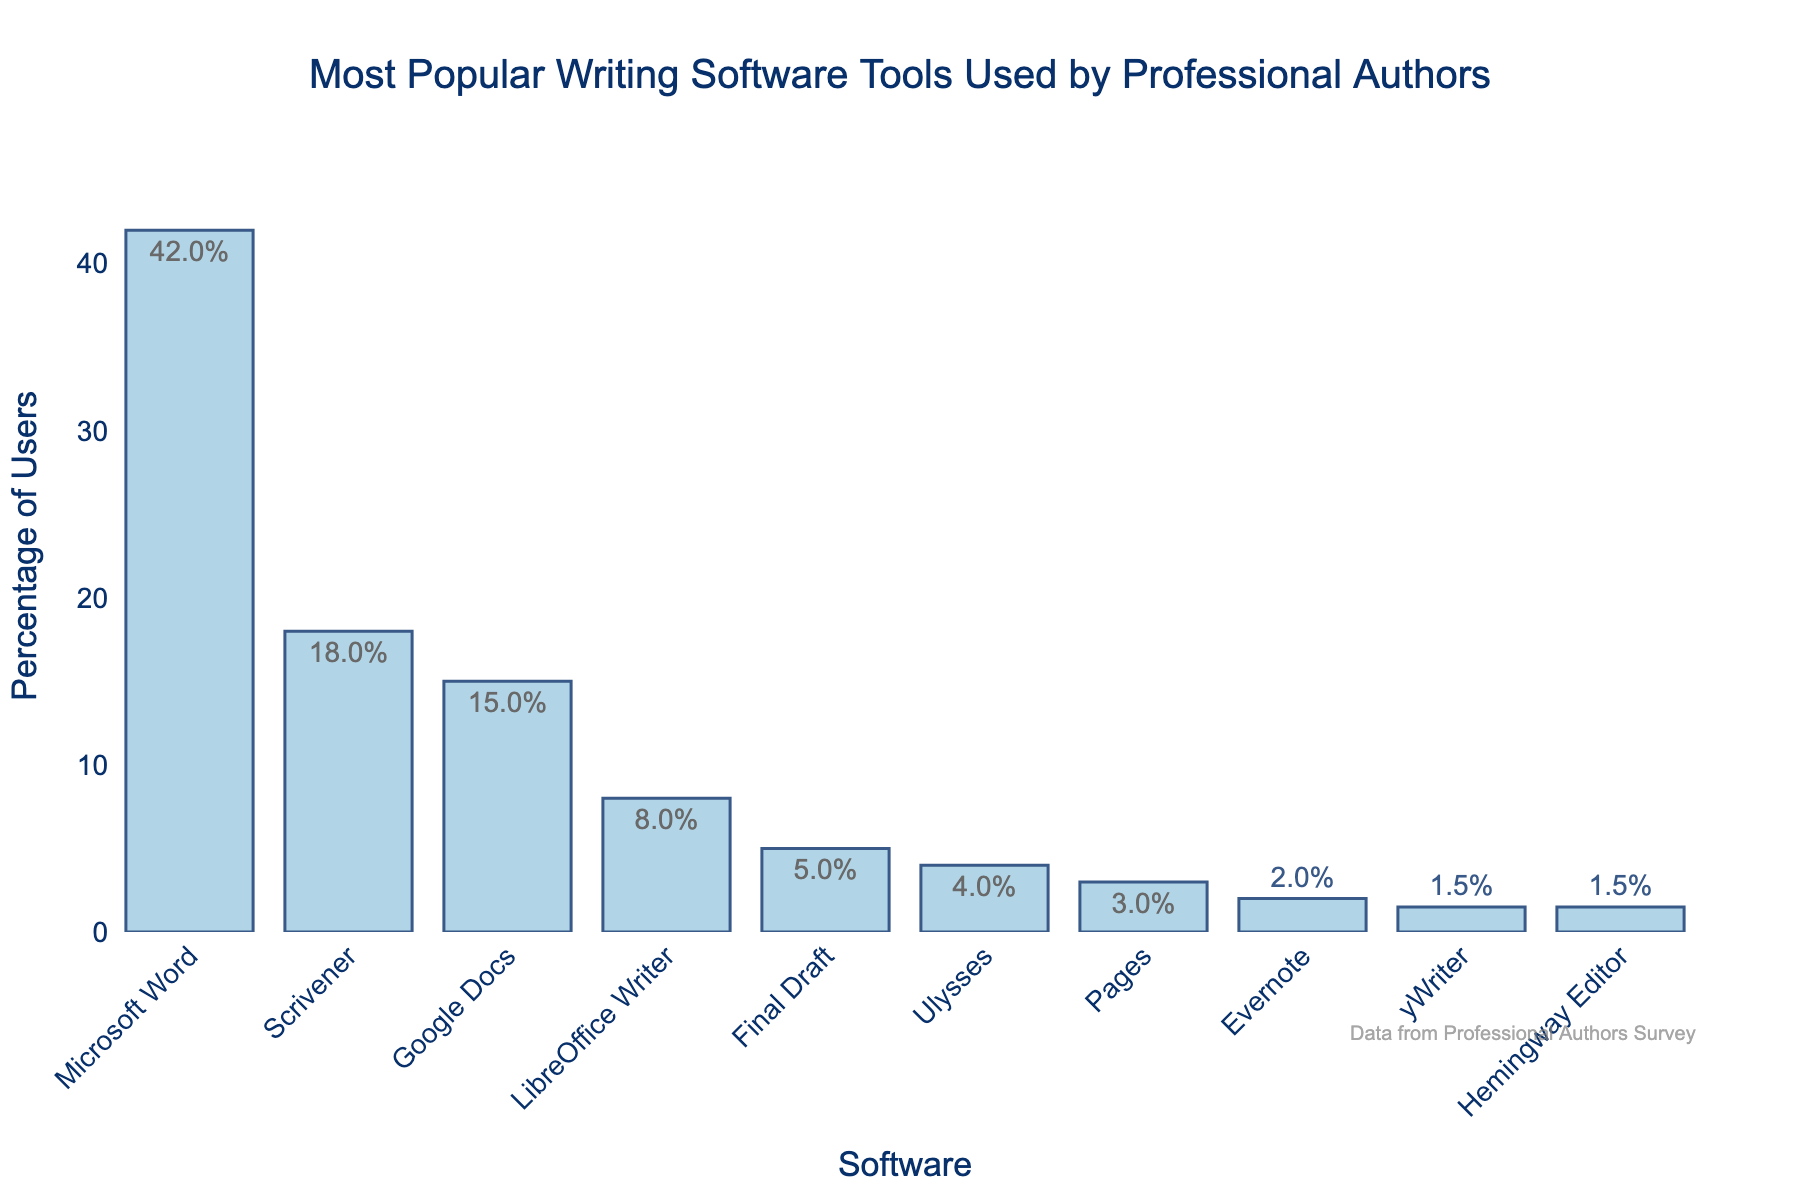Which software tool is the most popular among professional authors? The length of the bar representing Microsoft Word is the longest and it also has the highest percentage text (42%), indicating it is the most popular.
Answer: Microsoft Word What is the combined percentage of users for Scrivener, Google Docs, and LibreOffice Writer? The percentages are 18% for Scrivener, 15% for Google Docs, and 8% for LibreOffice Writer. Summing them up: 18 + 15 + 8 = 41%.
Answer: 41% How much more popular is Microsoft Word compared to Final Draft? The percentage for Microsoft Word is 42% and for Final Draft, it is 5%. Subtracting these: 42% - 5% = 37%.
Answer: 37% Which software tools have a percentage of users less than 5%? The bars representing Ulysses (4%), Pages (3%), Evernote (2%), yWriter (1.5%), and Hemingway Editor (1.5%) are shorter than the bar for 5%, so these tools have less than 5% users.
Answer: Ulysses, Pages, Evernote, yWriter, Hemingway Editor How many software tools have more than 15% of the users? The bars representing Microsoft Word (42%), Scrivener (18%), and Google Docs (15%) are considered. Google Docs just meets the threshold, so only Microsoft Word and Scrivener exceed 15%. Two tools meet this criteria.
Answer: 2 What is the average percentage of users for the three least popular software? The percentages are Evernote (2%), yWriter (1.5%), and Hemingway Editor (1.5%). Summing these and then dividing by 3: (2 + 1.5 + 1.5) / 3 = 5 / 3 ≈ 1.67%.
Answer: 1.67% Which software has the least number of users and what is its percentage? The bars at the same lowest height (shortest bars) are for yWriter and Hemingway Editor. Both bars represent 1.5% of users.
Answer: yWriter, Hemingway Editor, 1.5% What is the difference between the percentage of users of Scrivener and Google Docs? The percentage for Scrivener is 18% and for Google Docs, it is 15%. Subtracting these: 18% - 15% = 3%.
Answer: 3% Which software has the fourth highest usage among professional authors? The bar heights indicate that Microsoft Word is first, Scrivener is second, Google Docs is third, and LibreOffice Writer is fourth with 8%.
Answer: LibreOffice Writer If Microsoft Word's user percentage dropped by 10%, which software tool would become the most popular? Microsoft Word's percentage would drop from 42% to 32%. Scrivener, the second most popular, has 18%, which is less than 32%. Therefore, Microsoft Word would still be the most popular.
Answer: Microsoft Word 